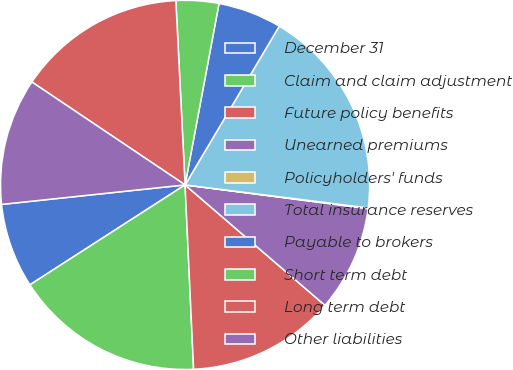Convert chart. <chart><loc_0><loc_0><loc_500><loc_500><pie_chart><fcel>December 31<fcel>Claim and claim adjustment<fcel>Future policy benefits<fcel>Unearned premiums<fcel>Policyholders' funds<fcel>Total insurance reserves<fcel>Payable to brokers<fcel>Short term debt<fcel>Long term debt<fcel>Other liabilities<nl><fcel>7.42%<fcel>16.63%<fcel>12.95%<fcel>9.26%<fcel>0.06%<fcel>18.47%<fcel>5.58%<fcel>3.74%<fcel>14.79%<fcel>11.1%<nl></chart> 